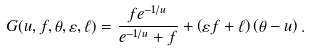<formula> <loc_0><loc_0><loc_500><loc_500>G ( u , f , \theta , \varepsilon , \ell ) = \frac { f e ^ { - 1 / u } } { e ^ { - 1 / u } + f } + \left ( \varepsilon f + \ell \right ) \left ( \theta - u \right ) .</formula> 